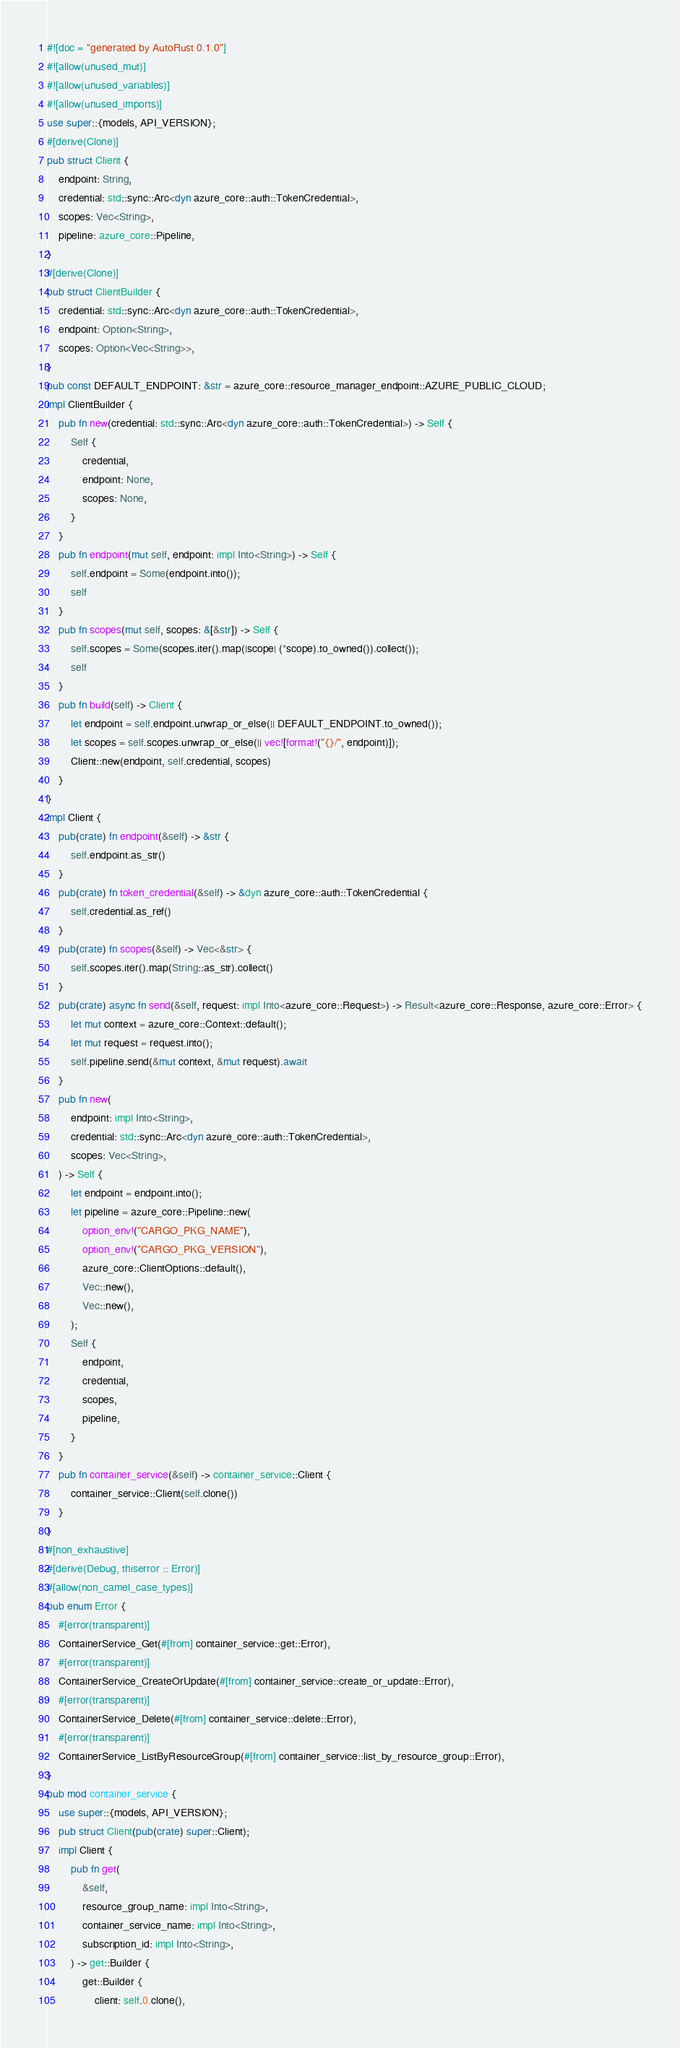<code> <loc_0><loc_0><loc_500><loc_500><_Rust_>#![doc = "generated by AutoRust 0.1.0"]
#![allow(unused_mut)]
#![allow(unused_variables)]
#![allow(unused_imports)]
use super::{models, API_VERSION};
#[derive(Clone)]
pub struct Client {
    endpoint: String,
    credential: std::sync::Arc<dyn azure_core::auth::TokenCredential>,
    scopes: Vec<String>,
    pipeline: azure_core::Pipeline,
}
#[derive(Clone)]
pub struct ClientBuilder {
    credential: std::sync::Arc<dyn azure_core::auth::TokenCredential>,
    endpoint: Option<String>,
    scopes: Option<Vec<String>>,
}
pub const DEFAULT_ENDPOINT: &str = azure_core::resource_manager_endpoint::AZURE_PUBLIC_CLOUD;
impl ClientBuilder {
    pub fn new(credential: std::sync::Arc<dyn azure_core::auth::TokenCredential>) -> Self {
        Self {
            credential,
            endpoint: None,
            scopes: None,
        }
    }
    pub fn endpoint(mut self, endpoint: impl Into<String>) -> Self {
        self.endpoint = Some(endpoint.into());
        self
    }
    pub fn scopes(mut self, scopes: &[&str]) -> Self {
        self.scopes = Some(scopes.iter().map(|scope| (*scope).to_owned()).collect());
        self
    }
    pub fn build(self) -> Client {
        let endpoint = self.endpoint.unwrap_or_else(|| DEFAULT_ENDPOINT.to_owned());
        let scopes = self.scopes.unwrap_or_else(|| vec![format!("{}/", endpoint)]);
        Client::new(endpoint, self.credential, scopes)
    }
}
impl Client {
    pub(crate) fn endpoint(&self) -> &str {
        self.endpoint.as_str()
    }
    pub(crate) fn token_credential(&self) -> &dyn azure_core::auth::TokenCredential {
        self.credential.as_ref()
    }
    pub(crate) fn scopes(&self) -> Vec<&str> {
        self.scopes.iter().map(String::as_str).collect()
    }
    pub(crate) async fn send(&self, request: impl Into<azure_core::Request>) -> Result<azure_core::Response, azure_core::Error> {
        let mut context = azure_core::Context::default();
        let mut request = request.into();
        self.pipeline.send(&mut context, &mut request).await
    }
    pub fn new(
        endpoint: impl Into<String>,
        credential: std::sync::Arc<dyn azure_core::auth::TokenCredential>,
        scopes: Vec<String>,
    ) -> Self {
        let endpoint = endpoint.into();
        let pipeline = azure_core::Pipeline::new(
            option_env!("CARGO_PKG_NAME"),
            option_env!("CARGO_PKG_VERSION"),
            azure_core::ClientOptions::default(),
            Vec::new(),
            Vec::new(),
        );
        Self {
            endpoint,
            credential,
            scopes,
            pipeline,
        }
    }
    pub fn container_service(&self) -> container_service::Client {
        container_service::Client(self.clone())
    }
}
#[non_exhaustive]
#[derive(Debug, thiserror :: Error)]
#[allow(non_camel_case_types)]
pub enum Error {
    #[error(transparent)]
    ContainerService_Get(#[from] container_service::get::Error),
    #[error(transparent)]
    ContainerService_CreateOrUpdate(#[from] container_service::create_or_update::Error),
    #[error(transparent)]
    ContainerService_Delete(#[from] container_service::delete::Error),
    #[error(transparent)]
    ContainerService_ListByResourceGroup(#[from] container_service::list_by_resource_group::Error),
}
pub mod container_service {
    use super::{models, API_VERSION};
    pub struct Client(pub(crate) super::Client);
    impl Client {
        pub fn get(
            &self,
            resource_group_name: impl Into<String>,
            container_service_name: impl Into<String>,
            subscription_id: impl Into<String>,
        ) -> get::Builder {
            get::Builder {
                client: self.0.clone(),</code> 